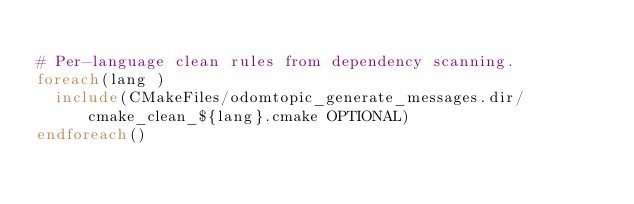<code> <loc_0><loc_0><loc_500><loc_500><_CMake_>
# Per-language clean rules from dependency scanning.
foreach(lang )
  include(CMakeFiles/odomtopic_generate_messages.dir/cmake_clean_${lang}.cmake OPTIONAL)
endforeach()
</code> 